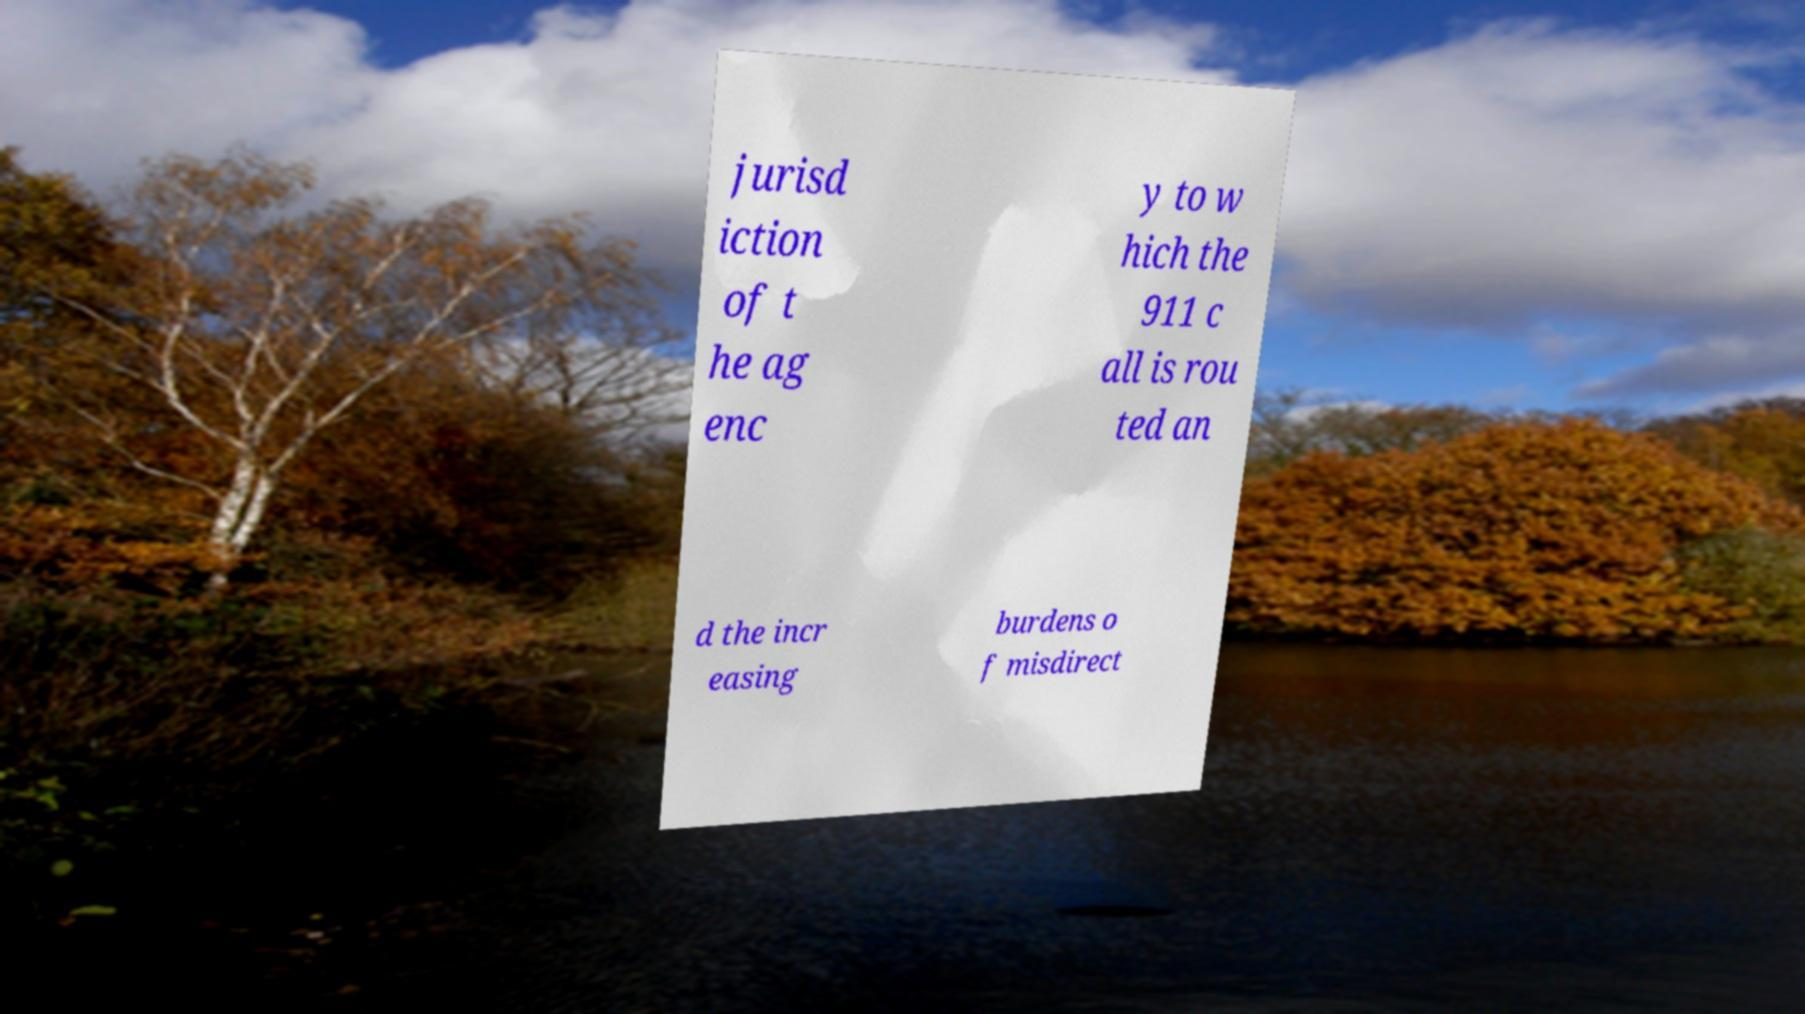Can you accurately transcribe the text from the provided image for me? jurisd iction of t he ag enc y to w hich the 911 c all is rou ted an d the incr easing burdens o f misdirect 